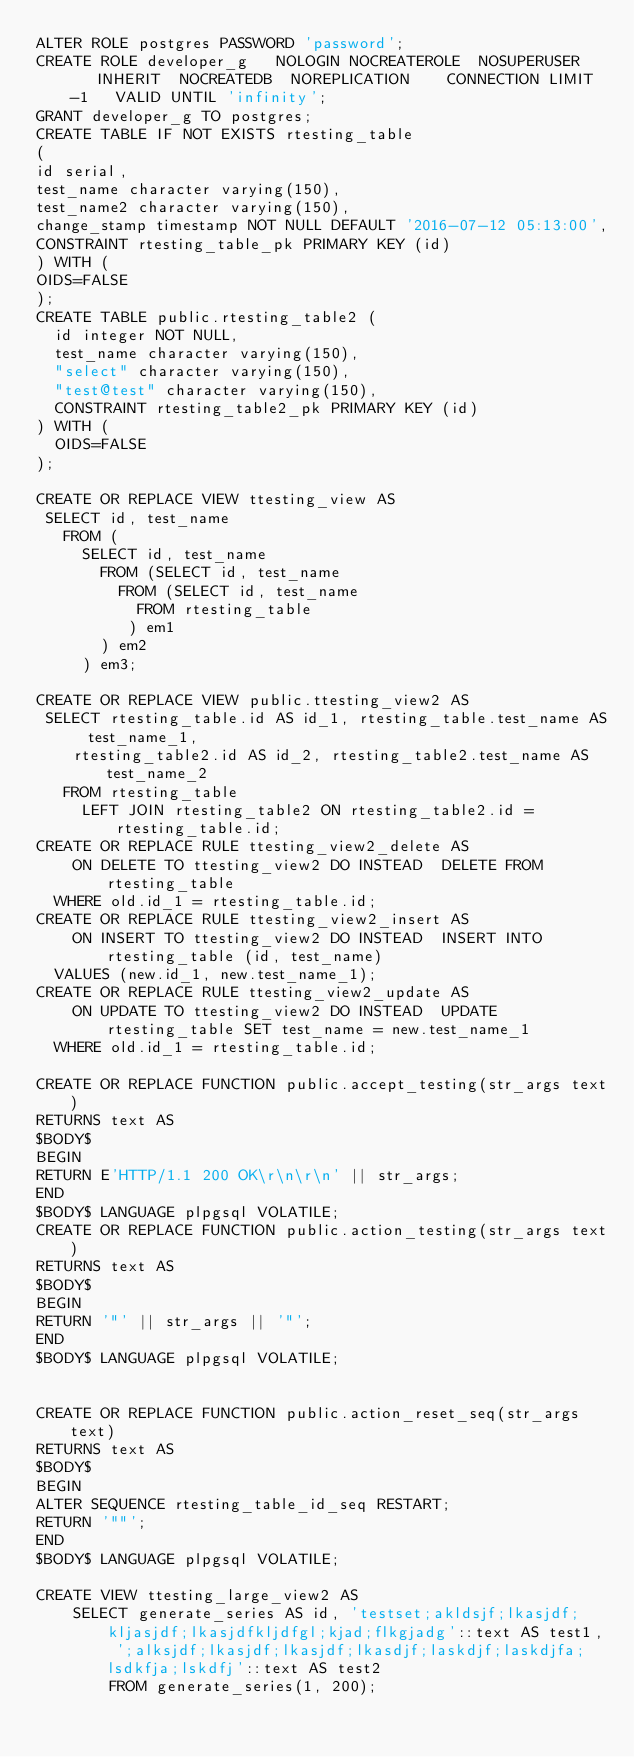<code> <loc_0><loc_0><loc_500><loc_500><_SQL_>ALTER ROLE postgres PASSWORD 'password';
CREATE ROLE developer_g   NOLOGIN NOCREATEROLE  NOSUPERUSER    INHERIT  NOCREATEDB  NOREPLICATION    CONNECTION LIMIT -1   VALID UNTIL 'infinity';
GRANT developer_g TO postgres;
CREATE TABLE IF NOT EXISTS rtesting_table
(
id serial,
test_name character varying(150),
test_name2 character varying(150),
change_stamp timestamp NOT NULL DEFAULT '2016-07-12 05:13:00',
CONSTRAINT rtesting_table_pk PRIMARY KEY (id)
) WITH (
OIDS=FALSE
);
CREATE TABLE public.rtesting_table2 (
  id integer NOT NULL,
  test_name character varying(150),
  "select" character varying(150),
  "test@test" character varying(150),
  CONSTRAINT rtesting_table2_pk PRIMARY KEY (id)
) WITH (
  OIDS=FALSE
);

CREATE OR REPLACE VIEW ttesting_view AS
 SELECT id, test_name
   FROM (
	 SELECT id, test_name
	   FROM (SELECT id, test_name
		 FROM (SELECT id, test_name
		   FROM rtesting_table
		  ) em1
	   ) em2
	 ) em3;

CREATE OR REPLACE VIEW public.ttesting_view2 AS
 SELECT rtesting_table.id AS id_1, rtesting_table.test_name AS test_name_1,
    rtesting_table2.id AS id_2, rtesting_table2.test_name AS test_name_2
   FROM rtesting_table
     LEFT JOIN rtesting_table2 ON rtesting_table2.id = rtesting_table.id;
CREATE OR REPLACE RULE ttesting_view2_delete AS
    ON DELETE TO ttesting_view2 DO INSTEAD  DELETE FROM rtesting_table
  WHERE old.id_1 = rtesting_table.id;
CREATE OR REPLACE RULE ttesting_view2_insert AS
    ON INSERT TO ttesting_view2 DO INSTEAD  INSERT INTO rtesting_table (id, test_name)
  VALUES (new.id_1, new.test_name_1);
CREATE OR REPLACE RULE ttesting_view2_update AS
    ON UPDATE TO ttesting_view2 DO INSTEAD  UPDATE rtesting_table SET test_name = new.test_name_1
  WHERE old.id_1 = rtesting_table.id;

CREATE OR REPLACE FUNCTION public.accept_testing(str_args text)
RETURNS text AS
$BODY$
BEGIN
RETURN E'HTTP/1.1 200 OK\r\n\r\n' || str_args;
END
$BODY$ LANGUAGE plpgsql VOLATILE;
CREATE OR REPLACE FUNCTION public.action_testing(str_args text)
RETURNS text AS
$BODY$
BEGIN
RETURN '"' || str_args || '"';
END
$BODY$ LANGUAGE plpgsql VOLATILE;


CREATE OR REPLACE FUNCTION public.action_reset_seq(str_args text)
RETURNS text AS
$BODY$
BEGIN
ALTER SEQUENCE rtesting_table_id_seq RESTART;
RETURN '""';
END
$BODY$ LANGUAGE plpgsql VOLATILE;

CREATE VIEW ttesting_large_view2 AS
	SELECT generate_series AS id, 'testset;akldsjf;lkasjdf;kljasjdf;lkasjdfkljdfgl;kjad;flkgjadg'::text AS test1, ';alksjdf;lkasjdf;lkasjdf;lkasdjf;laskdjf;laskdjfa;lsdkfja;lskdfj'::text AS test2
		FROM generate_series(1, 200);
</code> 